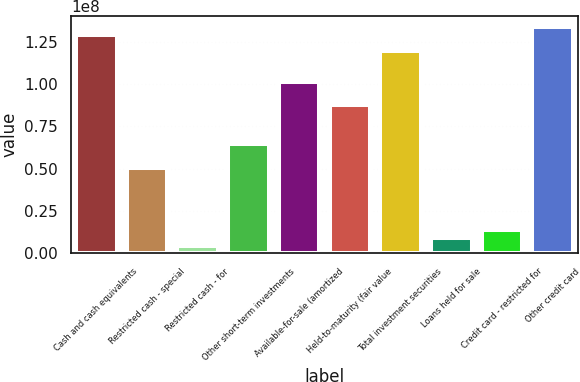Convert chart to OTSL. <chart><loc_0><loc_0><loc_500><loc_500><bar_chart><fcel>Cash and cash equivalents<fcel>Restricted cash - special<fcel>Restricted cash - for<fcel>Other short-term investments<fcel>Available-for-sale (amortized<fcel>Held-to-maturity (fair value<fcel>Total investment securities<fcel>Loans held for sale<fcel>Credit card - restricted for<fcel>Other credit card<nl><fcel>1.28859e+08<fcel>5.06231e+07<fcel>4.6021e+06<fcel>6.44294e+07<fcel>1.01246e+08<fcel>8.74399e+07<fcel>1.19655e+08<fcel>9.2042e+06<fcel>1.38063e+07<fcel>1.33461e+08<nl></chart> 